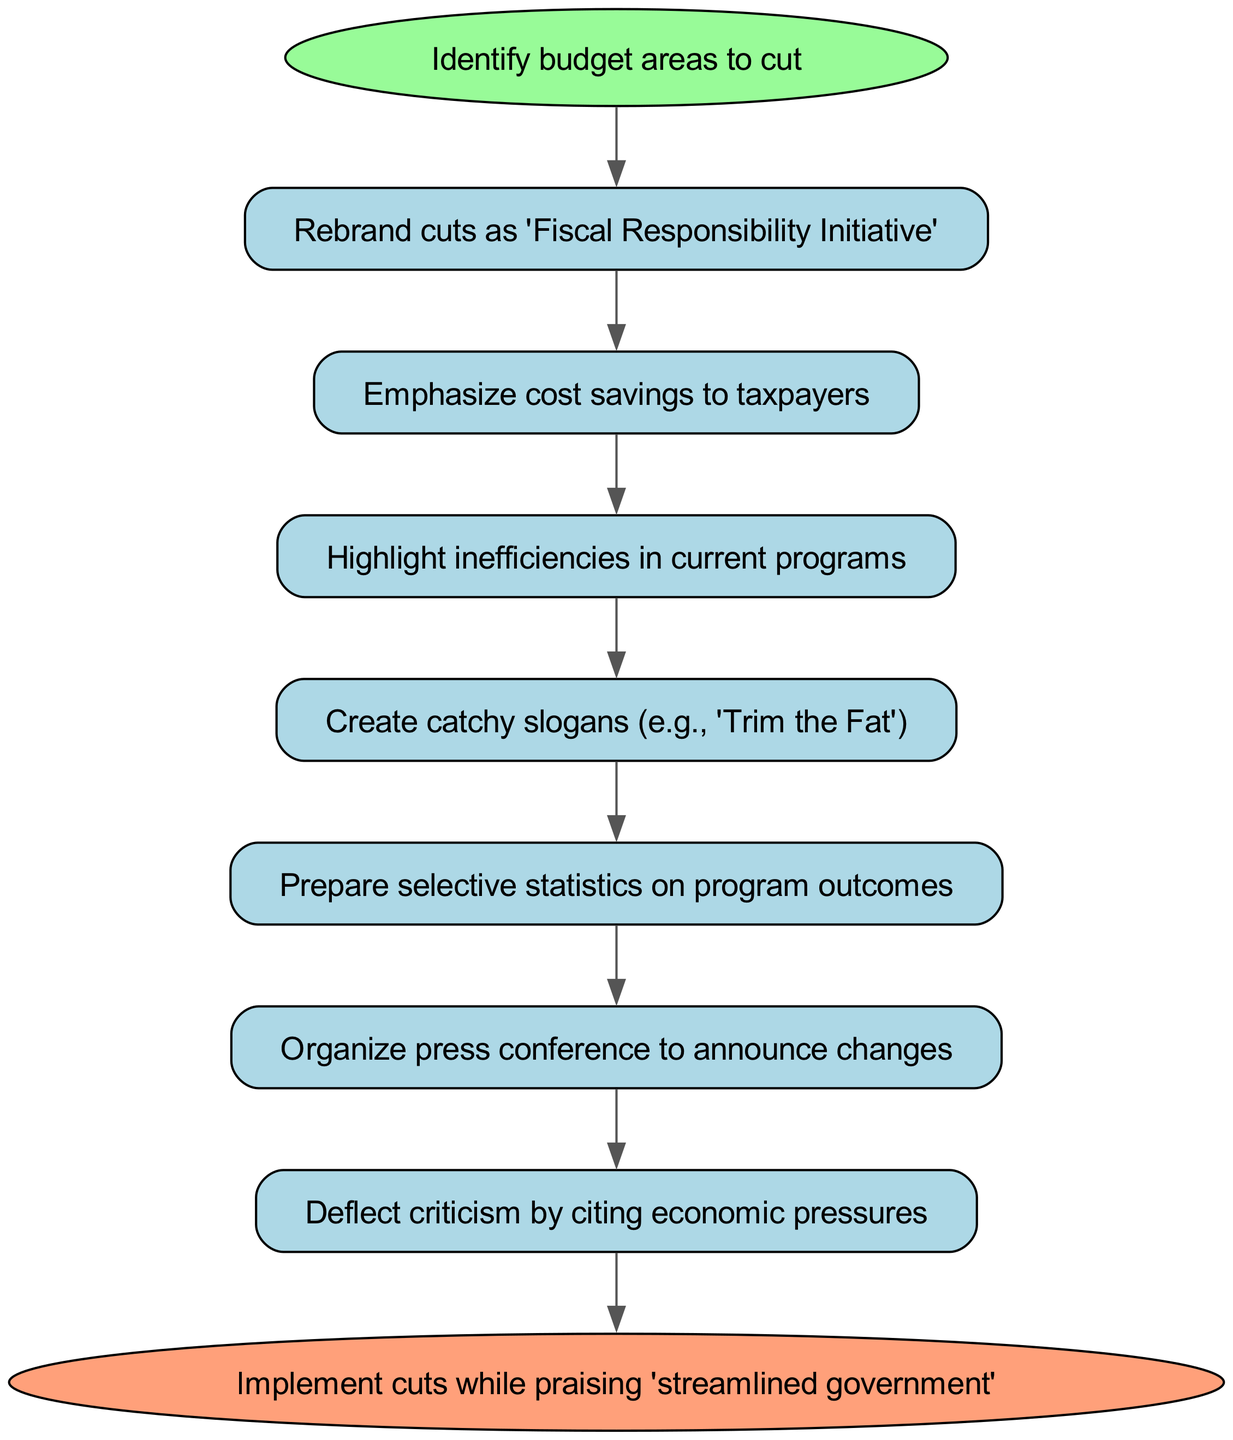What is the first step in the diagram? The first step identified in the diagram is "Identify budget areas to cut," which is the initial action to begin the reframing process.
Answer: Identify budget areas to cut How many steps are there in total in the diagram? The diagram contains a total of 8 steps, including both the starting and ending nodes as part of the process.
Answer: 8 What is the last step of the procedure? The last step in the procedure is "Implement cuts while praising 'streamlined government'," which represents the final action taken in the process.
Answer: Implement cuts while praising 'streamlined government' What node comes after emphasizing cost savings to taxpayers? After the node "Emphasize cost savings to taxpayers," the next node is "Highlight inefficiencies in current programs," indicating a continuation in the procedure.
Answer: Highlight inefficiencies in current programs How is the initial budget cut rebranded according to the diagram? The initial budget cut is rebranded as "Fiscal Responsibility Initiative," which suggests a positive spin on the cuts being made.
Answer: Fiscal Responsibility Initiative What action is taken after preparing selective statistics on program outcomes? After preparing selective statistics, the next action is to "Organize press conference to announce changes," continuing the communication strategy.
Answer: Organize press conference to announce changes What concept is highlighted in step three of the diagram? Step three highlights "inefficiencies in current programs," focusing on justifications for the budget cuts by pointing out areas that are not performing effectively.
Answer: Inefficiencies in current programs What is the purpose of creating catchy slogans in the reframing process? The purpose of creating catchy slogans, like "Trim the Fat," is to create an engaging message that resonates with the public and frames the cuts positively.
Answer: Create catchy slogans (e.g., 'Trim the Fat') 